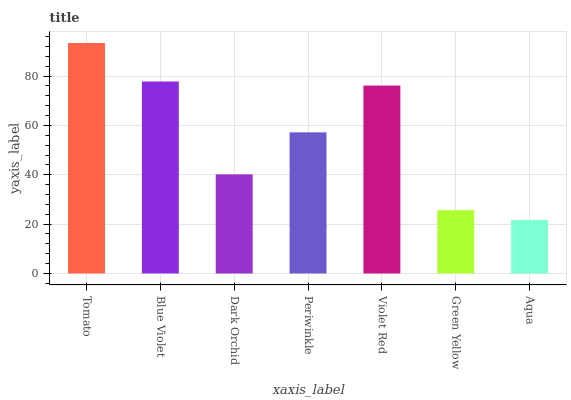Is Aqua the minimum?
Answer yes or no. Yes. Is Tomato the maximum?
Answer yes or no. Yes. Is Blue Violet the minimum?
Answer yes or no. No. Is Blue Violet the maximum?
Answer yes or no. No. Is Tomato greater than Blue Violet?
Answer yes or no. Yes. Is Blue Violet less than Tomato?
Answer yes or no. Yes. Is Blue Violet greater than Tomato?
Answer yes or no. No. Is Tomato less than Blue Violet?
Answer yes or no. No. Is Periwinkle the high median?
Answer yes or no. Yes. Is Periwinkle the low median?
Answer yes or no. Yes. Is Violet Red the high median?
Answer yes or no. No. Is Tomato the low median?
Answer yes or no. No. 